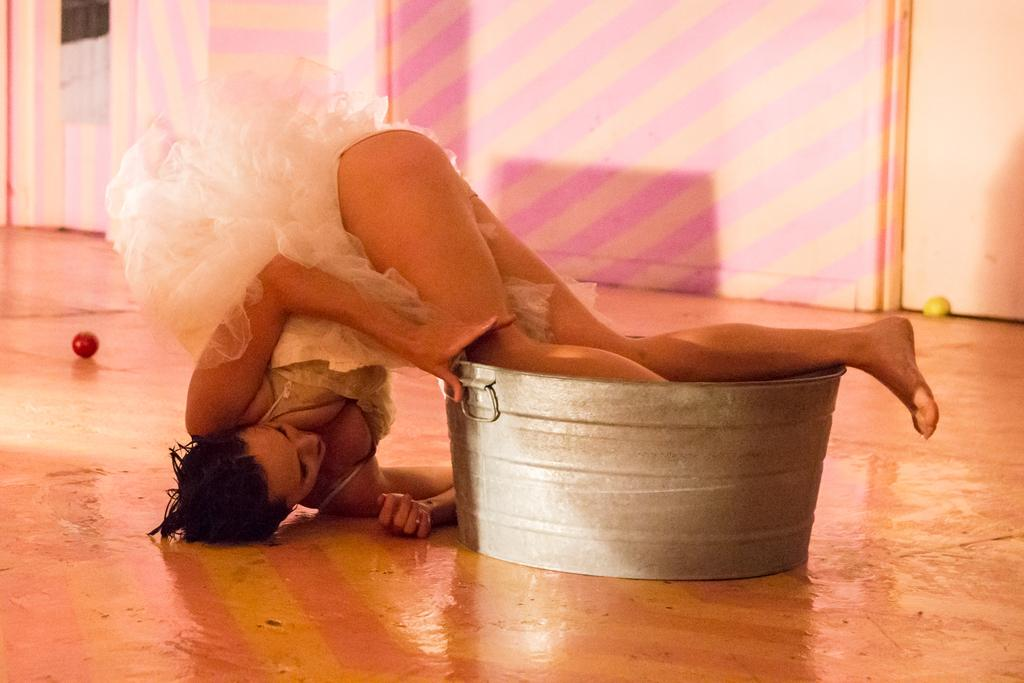What is the woman doing in the image? The woman is lying down on the floor. What is unique about the position of the woman's legs? The woman's legs are in a container. What other object can be seen on the floor? There is a ball on the floor. What is visible in the background of the image? There is a wall visible in the image. What type of organization is the woman affiliated with in the image? There is no indication of any organization in the image; it simply shows a woman lying down with her legs in a container and a ball on the floor. How much sand can be seen in the image? There is no sand present in the image. 